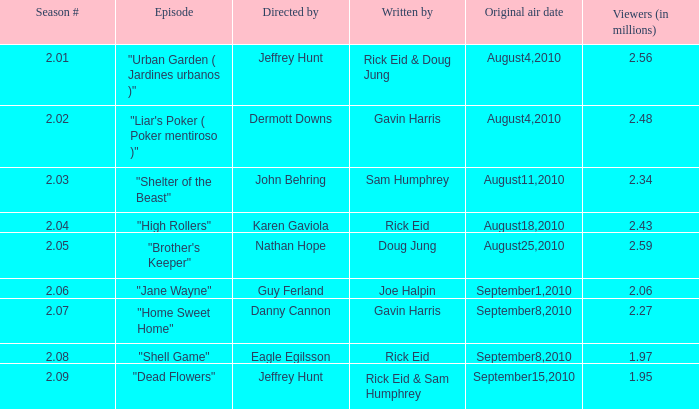If the season number is Rick Eid. Parse the full table. {'header': ['Season #', 'Episode', 'Directed by', 'Written by', 'Original air date', 'Viewers (in millions)'], 'rows': [['2.01', '"Urban Garden ( Jardines urbanos )"', 'Jeffrey Hunt', 'Rick Eid & Doug Jung', 'August4,2010', '2.56'], ['2.02', '"Liar\'s Poker ( Poker mentiroso )"', 'Dermott Downs', 'Gavin Harris', 'August4,2010', '2.48'], ['2.03', '"Shelter of the Beast"', 'John Behring', 'Sam Humphrey', 'August11,2010', '2.34'], ['2.04', '"High Rollers"', 'Karen Gaviola', 'Rick Eid', 'August18,2010', '2.43'], ['2.05', '"Brother\'s Keeper"', 'Nathan Hope', 'Doug Jung', 'August25,2010', '2.59'], ['2.06', '"Jane Wayne"', 'Guy Ferland', 'Joe Halpin', 'September1,2010', '2.06'], ['2.07', '"Home Sweet Home"', 'Danny Cannon', 'Gavin Harris', 'September8,2010', '2.27'], ['2.08', '"Shell Game"', 'Eagle Egilsson', 'Rick Eid', 'September8,2010', '1.97'], ['2.09', '"Dead Flowers"', 'Jeffrey Hunt', 'Rick Eid & Sam Humphrey', 'September15,2010', '1.95']]} 